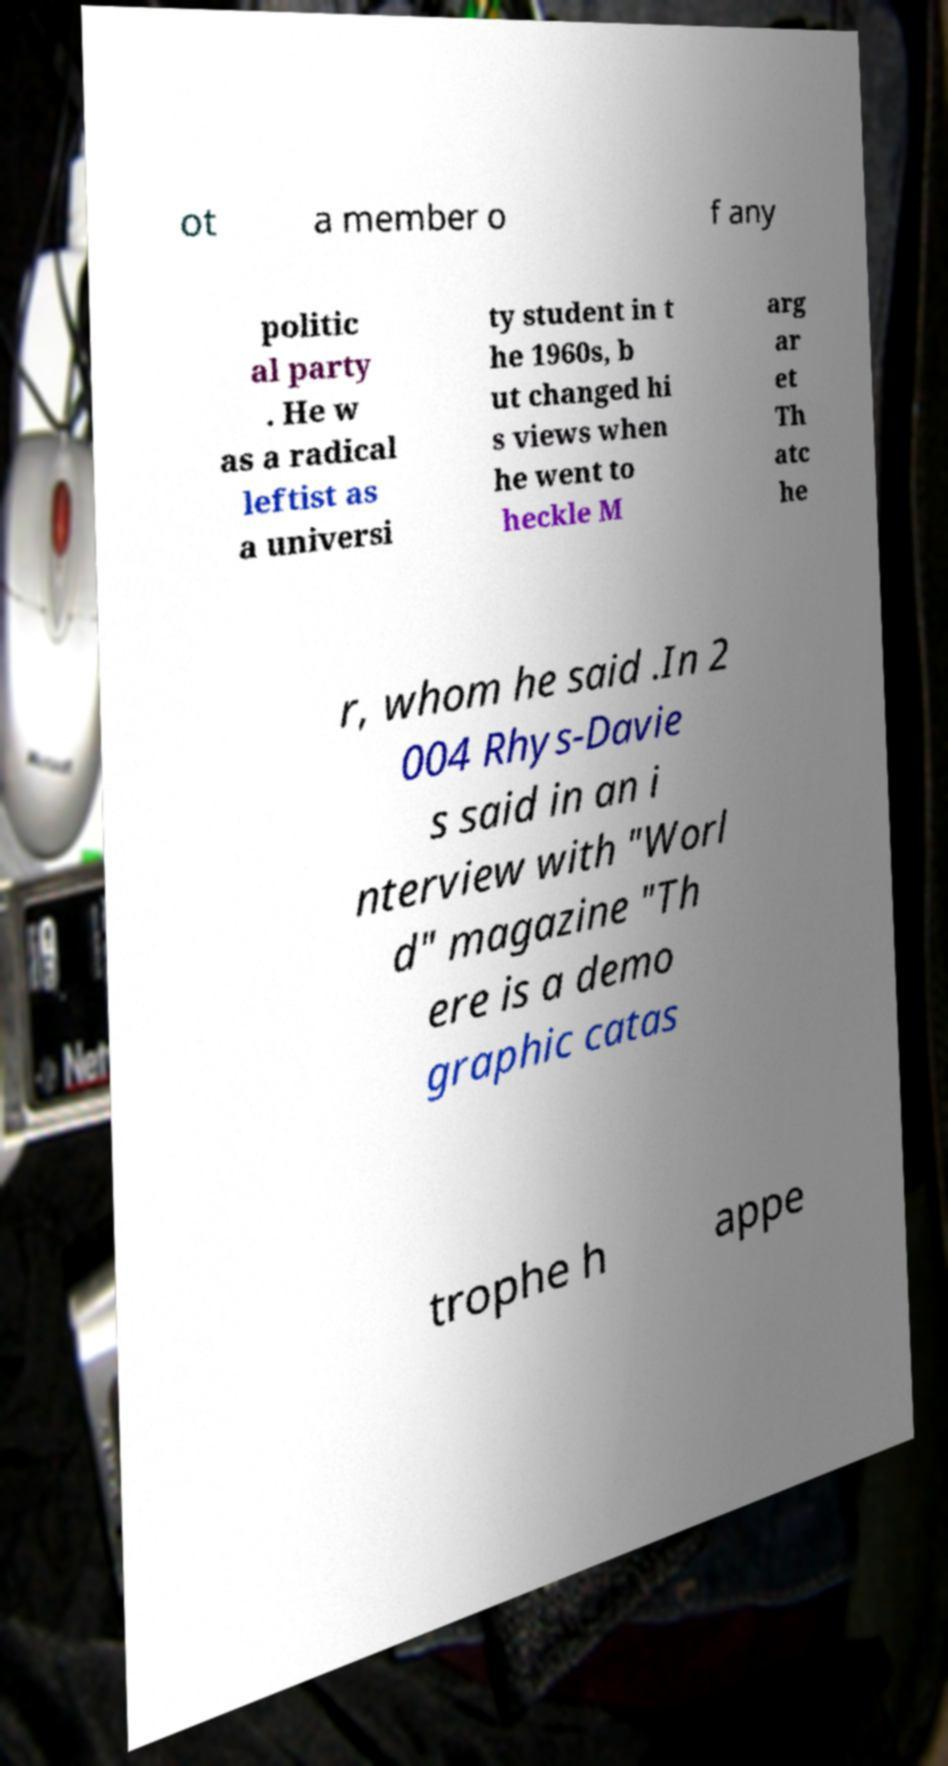Please identify and transcribe the text found in this image. ot a member o f any politic al party . He w as a radical leftist as a universi ty student in t he 1960s, b ut changed hi s views when he went to heckle M arg ar et Th atc he r, whom he said .In 2 004 Rhys-Davie s said in an i nterview with "Worl d" magazine "Th ere is a demo graphic catas trophe h appe 